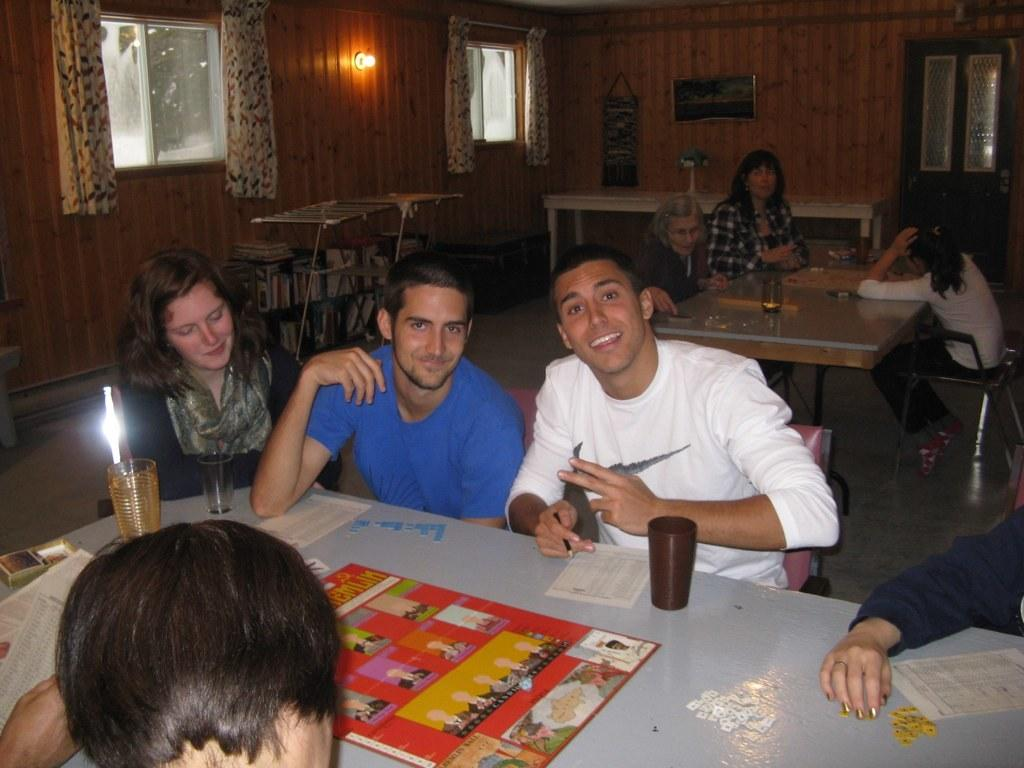What is the main subject of the image? The main subject of the image is a group of people. What are the people doing in the image? The people are sitting on chairs in the image. What is present on the table in the image? There are cups and a sheet on the table in the image. How does the bubble affect the group of people in the image? There is no bubble present in the image, so it cannot affect the group of people. 